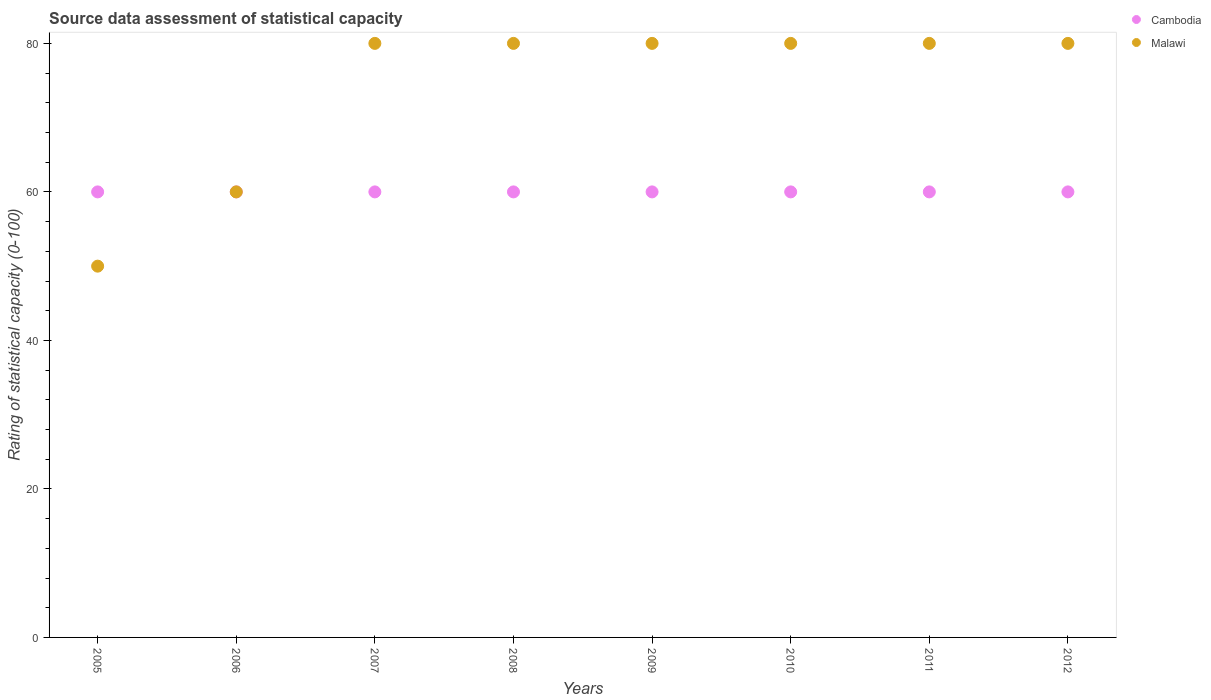How many different coloured dotlines are there?
Keep it short and to the point. 2. Is the number of dotlines equal to the number of legend labels?
Make the answer very short. Yes. What is the rating of statistical capacity in Malawi in 2011?
Ensure brevity in your answer.  80. Across all years, what is the maximum rating of statistical capacity in Cambodia?
Your response must be concise. 60. Across all years, what is the minimum rating of statistical capacity in Cambodia?
Make the answer very short. 60. What is the total rating of statistical capacity in Malawi in the graph?
Your response must be concise. 590. What is the difference between the rating of statistical capacity in Cambodia in 2010 and the rating of statistical capacity in Malawi in 2009?
Give a very brief answer. -20. What is the average rating of statistical capacity in Cambodia per year?
Give a very brief answer. 60. In the year 2012, what is the difference between the rating of statistical capacity in Malawi and rating of statistical capacity in Cambodia?
Your answer should be compact. 20. What is the ratio of the rating of statistical capacity in Cambodia in 2006 to that in 2010?
Your answer should be very brief. 1. Is the rating of statistical capacity in Cambodia in 2007 less than that in 2012?
Your response must be concise. No. Is the rating of statistical capacity in Malawi strictly greater than the rating of statistical capacity in Cambodia over the years?
Your answer should be compact. No. Is the rating of statistical capacity in Malawi strictly less than the rating of statistical capacity in Cambodia over the years?
Keep it short and to the point. No. How many years are there in the graph?
Make the answer very short. 8. What is the difference between two consecutive major ticks on the Y-axis?
Your answer should be very brief. 20. Does the graph contain any zero values?
Your response must be concise. No. How are the legend labels stacked?
Make the answer very short. Vertical. What is the title of the graph?
Offer a terse response. Source data assessment of statistical capacity. Does "Malawi" appear as one of the legend labels in the graph?
Keep it short and to the point. Yes. What is the label or title of the Y-axis?
Provide a short and direct response. Rating of statistical capacity (0-100). What is the Rating of statistical capacity (0-100) of Malawi in 2005?
Offer a terse response. 50. What is the Rating of statistical capacity (0-100) of Cambodia in 2007?
Your answer should be compact. 60. What is the Rating of statistical capacity (0-100) of Malawi in 2007?
Your answer should be compact. 80. What is the Rating of statistical capacity (0-100) in Cambodia in 2008?
Give a very brief answer. 60. What is the Rating of statistical capacity (0-100) in Malawi in 2010?
Give a very brief answer. 80. What is the Rating of statistical capacity (0-100) of Malawi in 2011?
Your answer should be very brief. 80. What is the Rating of statistical capacity (0-100) in Cambodia in 2012?
Offer a terse response. 60. Across all years, what is the maximum Rating of statistical capacity (0-100) of Cambodia?
Offer a terse response. 60. Across all years, what is the minimum Rating of statistical capacity (0-100) of Malawi?
Provide a succinct answer. 50. What is the total Rating of statistical capacity (0-100) in Cambodia in the graph?
Provide a succinct answer. 480. What is the total Rating of statistical capacity (0-100) in Malawi in the graph?
Offer a very short reply. 590. What is the difference between the Rating of statistical capacity (0-100) of Cambodia in 2005 and that in 2007?
Provide a short and direct response. 0. What is the difference between the Rating of statistical capacity (0-100) of Malawi in 2005 and that in 2007?
Keep it short and to the point. -30. What is the difference between the Rating of statistical capacity (0-100) of Cambodia in 2005 and that in 2008?
Your response must be concise. 0. What is the difference between the Rating of statistical capacity (0-100) of Cambodia in 2005 and that in 2009?
Your answer should be very brief. 0. What is the difference between the Rating of statistical capacity (0-100) of Cambodia in 2005 and that in 2010?
Give a very brief answer. 0. What is the difference between the Rating of statistical capacity (0-100) of Malawi in 2005 and that in 2011?
Your answer should be compact. -30. What is the difference between the Rating of statistical capacity (0-100) of Malawi in 2006 and that in 2007?
Make the answer very short. -20. What is the difference between the Rating of statistical capacity (0-100) in Cambodia in 2006 and that in 2008?
Keep it short and to the point. 0. What is the difference between the Rating of statistical capacity (0-100) of Malawi in 2006 and that in 2009?
Offer a very short reply. -20. What is the difference between the Rating of statistical capacity (0-100) of Cambodia in 2006 and that in 2010?
Ensure brevity in your answer.  0. What is the difference between the Rating of statistical capacity (0-100) in Cambodia in 2006 and that in 2011?
Your answer should be very brief. 0. What is the difference between the Rating of statistical capacity (0-100) in Malawi in 2006 and that in 2011?
Offer a terse response. -20. What is the difference between the Rating of statistical capacity (0-100) of Cambodia in 2007 and that in 2008?
Make the answer very short. 0. What is the difference between the Rating of statistical capacity (0-100) of Malawi in 2007 and that in 2008?
Ensure brevity in your answer.  0. What is the difference between the Rating of statistical capacity (0-100) of Cambodia in 2007 and that in 2009?
Make the answer very short. 0. What is the difference between the Rating of statistical capacity (0-100) of Malawi in 2007 and that in 2009?
Provide a short and direct response. 0. What is the difference between the Rating of statistical capacity (0-100) in Cambodia in 2007 and that in 2012?
Your response must be concise. 0. What is the difference between the Rating of statistical capacity (0-100) in Malawi in 2007 and that in 2012?
Your answer should be compact. 0. What is the difference between the Rating of statistical capacity (0-100) in Malawi in 2008 and that in 2011?
Give a very brief answer. 0. What is the difference between the Rating of statistical capacity (0-100) in Cambodia in 2008 and that in 2012?
Your answer should be very brief. 0. What is the difference between the Rating of statistical capacity (0-100) in Malawi in 2008 and that in 2012?
Your answer should be very brief. 0. What is the difference between the Rating of statistical capacity (0-100) of Cambodia in 2009 and that in 2010?
Give a very brief answer. 0. What is the difference between the Rating of statistical capacity (0-100) of Malawi in 2009 and that in 2011?
Give a very brief answer. 0. What is the difference between the Rating of statistical capacity (0-100) of Malawi in 2009 and that in 2012?
Give a very brief answer. 0. What is the difference between the Rating of statistical capacity (0-100) of Cambodia in 2010 and that in 2011?
Your answer should be very brief. 0. What is the difference between the Rating of statistical capacity (0-100) of Malawi in 2010 and that in 2011?
Keep it short and to the point. 0. What is the difference between the Rating of statistical capacity (0-100) in Cambodia in 2010 and that in 2012?
Your response must be concise. 0. What is the difference between the Rating of statistical capacity (0-100) of Malawi in 2011 and that in 2012?
Give a very brief answer. 0. What is the difference between the Rating of statistical capacity (0-100) of Cambodia in 2005 and the Rating of statistical capacity (0-100) of Malawi in 2006?
Make the answer very short. 0. What is the difference between the Rating of statistical capacity (0-100) in Cambodia in 2005 and the Rating of statistical capacity (0-100) in Malawi in 2007?
Provide a succinct answer. -20. What is the difference between the Rating of statistical capacity (0-100) in Cambodia in 2005 and the Rating of statistical capacity (0-100) in Malawi in 2009?
Make the answer very short. -20. What is the difference between the Rating of statistical capacity (0-100) of Cambodia in 2005 and the Rating of statistical capacity (0-100) of Malawi in 2010?
Your answer should be compact. -20. What is the difference between the Rating of statistical capacity (0-100) in Cambodia in 2005 and the Rating of statistical capacity (0-100) in Malawi in 2011?
Your answer should be compact. -20. What is the difference between the Rating of statistical capacity (0-100) in Cambodia in 2006 and the Rating of statistical capacity (0-100) in Malawi in 2007?
Your answer should be compact. -20. What is the difference between the Rating of statistical capacity (0-100) of Cambodia in 2006 and the Rating of statistical capacity (0-100) of Malawi in 2008?
Make the answer very short. -20. What is the difference between the Rating of statistical capacity (0-100) of Cambodia in 2006 and the Rating of statistical capacity (0-100) of Malawi in 2010?
Your answer should be compact. -20. What is the difference between the Rating of statistical capacity (0-100) of Cambodia in 2006 and the Rating of statistical capacity (0-100) of Malawi in 2011?
Your answer should be compact. -20. What is the difference between the Rating of statistical capacity (0-100) of Cambodia in 2006 and the Rating of statistical capacity (0-100) of Malawi in 2012?
Keep it short and to the point. -20. What is the difference between the Rating of statistical capacity (0-100) in Cambodia in 2007 and the Rating of statistical capacity (0-100) in Malawi in 2008?
Your answer should be very brief. -20. What is the difference between the Rating of statistical capacity (0-100) in Cambodia in 2007 and the Rating of statistical capacity (0-100) in Malawi in 2010?
Your answer should be very brief. -20. What is the difference between the Rating of statistical capacity (0-100) of Cambodia in 2008 and the Rating of statistical capacity (0-100) of Malawi in 2011?
Give a very brief answer. -20. What is the difference between the Rating of statistical capacity (0-100) in Cambodia in 2009 and the Rating of statistical capacity (0-100) in Malawi in 2010?
Your answer should be very brief. -20. What is the difference between the Rating of statistical capacity (0-100) of Cambodia in 2010 and the Rating of statistical capacity (0-100) of Malawi in 2011?
Offer a terse response. -20. What is the difference between the Rating of statistical capacity (0-100) of Cambodia in 2010 and the Rating of statistical capacity (0-100) of Malawi in 2012?
Give a very brief answer. -20. What is the difference between the Rating of statistical capacity (0-100) of Cambodia in 2011 and the Rating of statistical capacity (0-100) of Malawi in 2012?
Provide a succinct answer. -20. What is the average Rating of statistical capacity (0-100) in Malawi per year?
Ensure brevity in your answer.  73.75. In the year 2008, what is the difference between the Rating of statistical capacity (0-100) in Cambodia and Rating of statistical capacity (0-100) in Malawi?
Your answer should be very brief. -20. In the year 2011, what is the difference between the Rating of statistical capacity (0-100) in Cambodia and Rating of statistical capacity (0-100) in Malawi?
Give a very brief answer. -20. What is the ratio of the Rating of statistical capacity (0-100) in Cambodia in 2005 to that in 2006?
Your answer should be very brief. 1. What is the ratio of the Rating of statistical capacity (0-100) of Malawi in 2005 to that in 2006?
Provide a short and direct response. 0.83. What is the ratio of the Rating of statistical capacity (0-100) in Malawi in 2005 to that in 2007?
Provide a short and direct response. 0.62. What is the ratio of the Rating of statistical capacity (0-100) of Malawi in 2005 to that in 2008?
Make the answer very short. 0.62. What is the ratio of the Rating of statistical capacity (0-100) of Cambodia in 2005 to that in 2009?
Your answer should be compact. 1. What is the ratio of the Rating of statistical capacity (0-100) of Malawi in 2005 to that in 2009?
Make the answer very short. 0.62. What is the ratio of the Rating of statistical capacity (0-100) in Malawi in 2005 to that in 2010?
Give a very brief answer. 0.62. What is the ratio of the Rating of statistical capacity (0-100) in Malawi in 2005 to that in 2012?
Your response must be concise. 0.62. What is the ratio of the Rating of statistical capacity (0-100) of Malawi in 2006 to that in 2007?
Ensure brevity in your answer.  0.75. What is the ratio of the Rating of statistical capacity (0-100) of Malawi in 2006 to that in 2008?
Ensure brevity in your answer.  0.75. What is the ratio of the Rating of statistical capacity (0-100) of Cambodia in 2006 to that in 2009?
Your answer should be very brief. 1. What is the ratio of the Rating of statistical capacity (0-100) of Malawi in 2006 to that in 2009?
Your answer should be very brief. 0.75. What is the ratio of the Rating of statistical capacity (0-100) of Cambodia in 2006 to that in 2010?
Provide a short and direct response. 1. What is the ratio of the Rating of statistical capacity (0-100) in Malawi in 2006 to that in 2011?
Give a very brief answer. 0.75. What is the ratio of the Rating of statistical capacity (0-100) of Cambodia in 2006 to that in 2012?
Ensure brevity in your answer.  1. What is the ratio of the Rating of statistical capacity (0-100) in Malawi in 2006 to that in 2012?
Provide a succinct answer. 0.75. What is the ratio of the Rating of statistical capacity (0-100) of Cambodia in 2007 to that in 2008?
Give a very brief answer. 1. What is the ratio of the Rating of statistical capacity (0-100) of Cambodia in 2007 to that in 2009?
Keep it short and to the point. 1. What is the ratio of the Rating of statistical capacity (0-100) in Malawi in 2007 to that in 2009?
Give a very brief answer. 1. What is the ratio of the Rating of statistical capacity (0-100) of Cambodia in 2007 to that in 2010?
Give a very brief answer. 1. What is the ratio of the Rating of statistical capacity (0-100) in Malawi in 2007 to that in 2010?
Provide a succinct answer. 1. What is the ratio of the Rating of statistical capacity (0-100) of Cambodia in 2007 to that in 2011?
Offer a very short reply. 1. What is the ratio of the Rating of statistical capacity (0-100) of Malawi in 2007 to that in 2011?
Make the answer very short. 1. What is the ratio of the Rating of statistical capacity (0-100) in Malawi in 2007 to that in 2012?
Give a very brief answer. 1. What is the ratio of the Rating of statistical capacity (0-100) in Malawi in 2008 to that in 2010?
Offer a very short reply. 1. What is the ratio of the Rating of statistical capacity (0-100) in Malawi in 2008 to that in 2011?
Make the answer very short. 1. What is the ratio of the Rating of statistical capacity (0-100) of Cambodia in 2008 to that in 2012?
Ensure brevity in your answer.  1. What is the ratio of the Rating of statistical capacity (0-100) of Malawi in 2009 to that in 2010?
Offer a very short reply. 1. What is the ratio of the Rating of statistical capacity (0-100) of Malawi in 2009 to that in 2011?
Your response must be concise. 1. What is the ratio of the Rating of statistical capacity (0-100) in Malawi in 2009 to that in 2012?
Ensure brevity in your answer.  1. What is the ratio of the Rating of statistical capacity (0-100) of Cambodia in 2011 to that in 2012?
Your answer should be compact. 1. What is the difference between the highest and the second highest Rating of statistical capacity (0-100) in Malawi?
Provide a succinct answer. 0. What is the difference between the highest and the lowest Rating of statistical capacity (0-100) in Cambodia?
Provide a succinct answer. 0. 